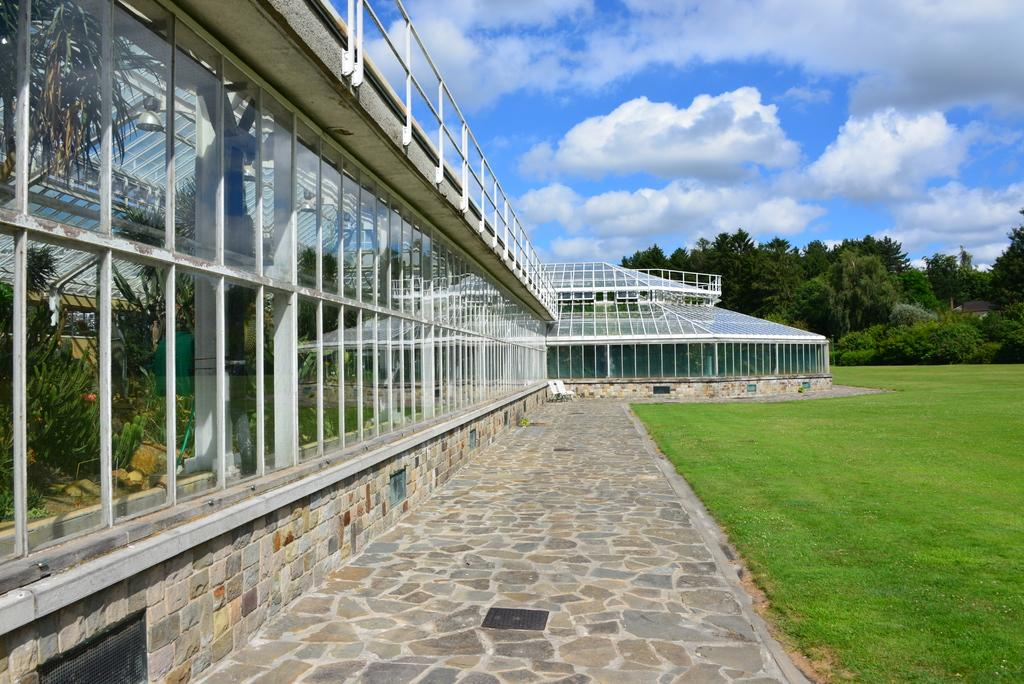What type of structures can be seen in the image? There are buildings in the image. What is on top of the buildings? There are glasses on the buildings. What can be seen on the ground in the image? There is a path visible in the image, and there is grass as well. What is visible in the background of the image? There are trees and the sky in the background of the image. What type of bells can be heard ringing in the image? There are no bells present in the image, and therefore no sound can be heard. How many horses are visible in the image? There are no horses present in the image. 